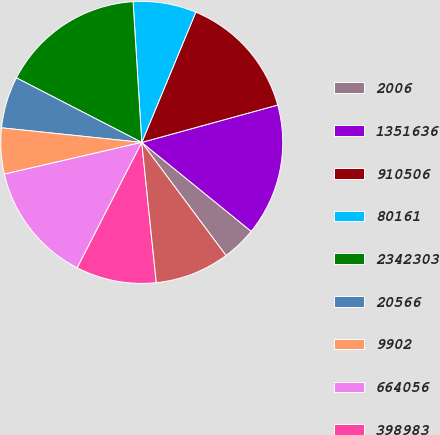<chart> <loc_0><loc_0><loc_500><loc_500><pie_chart><fcel>2006<fcel>1351636<fcel>910506<fcel>80161<fcel>2342303<fcel>20566<fcel>9902<fcel>664056<fcel>398983<fcel>270292<nl><fcel>3.95%<fcel>15.13%<fcel>14.47%<fcel>7.24%<fcel>16.45%<fcel>5.92%<fcel>5.26%<fcel>13.82%<fcel>9.21%<fcel>8.55%<nl></chart> 